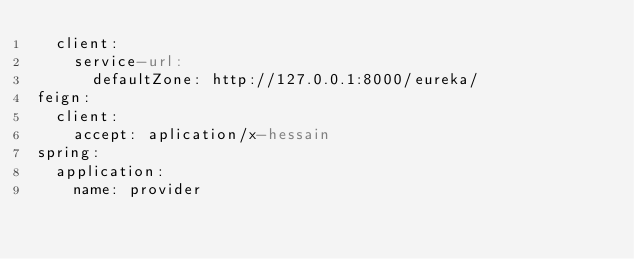<code> <loc_0><loc_0><loc_500><loc_500><_YAML_>  client:
    service-url:
      defaultZone: http://127.0.0.1:8000/eureka/
feign:
  client:
    accept: aplication/x-hessain
spring:
  application:
    name: provider

</code> 